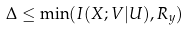Convert formula to latex. <formula><loc_0><loc_0><loc_500><loc_500>\Delta & \leq \min ( I ( X ; V | U ) , R _ { y } )</formula> 